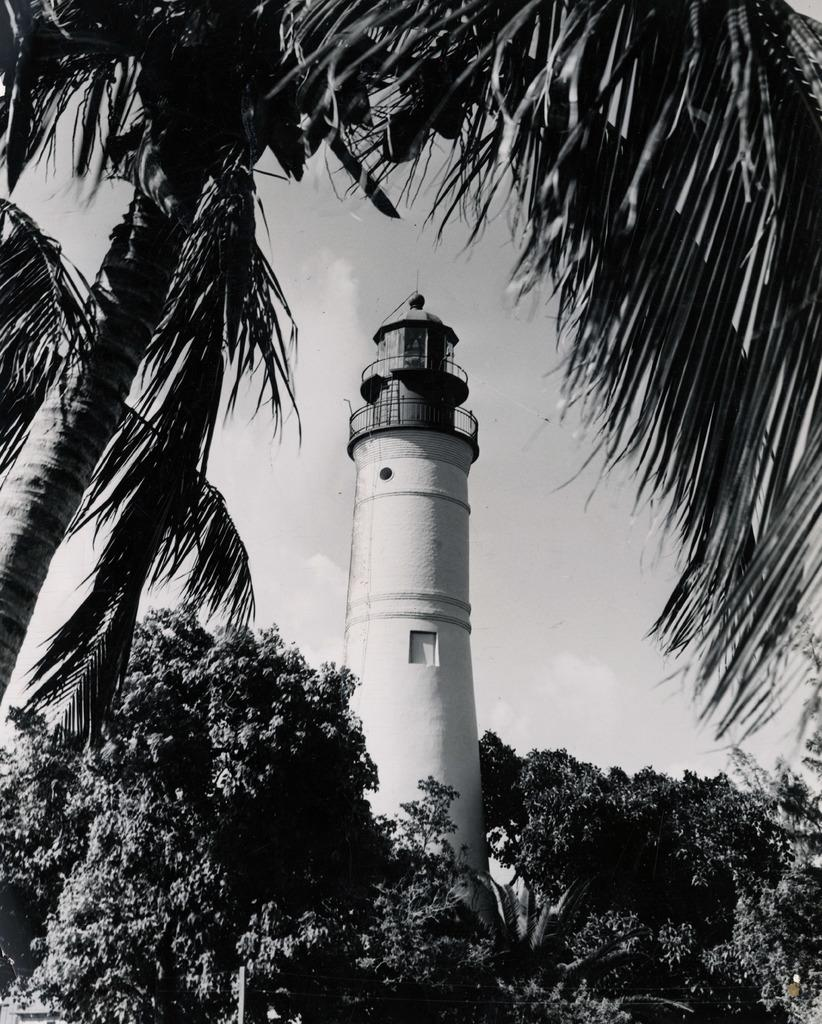What is the color scheme of the image? The image is black and white. What is the main structure in the middle of the image? There is a tower in the middle of the image. What type of vegetation is at the bottom of the image? There are trees at the bottom of the image. Can you identify a specific type of tree on the left side of the image? Yes, there is a coconut tree on the left side of the image. How many geese are resting under the umbrella in the image? There are no geese or umbrellas present in the image. What part of the human body can be seen interacting with the coconut tree in the image? There are no human body parts visible in the image, as it is a black and white image of a tower, trees, and a coconut tree. 